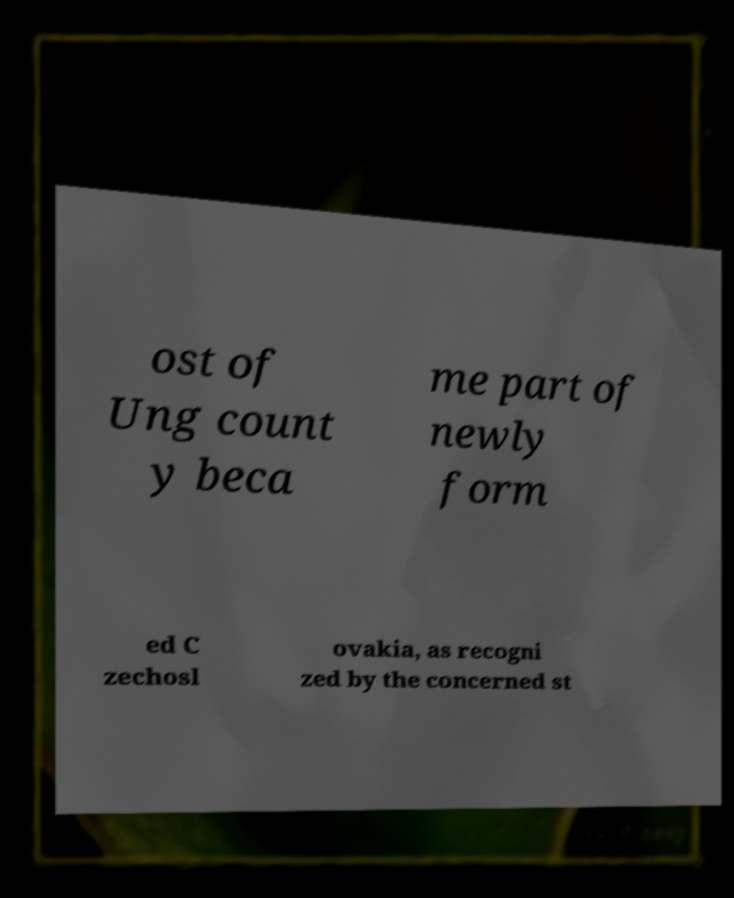Can you accurately transcribe the text from the provided image for me? ost of Ung count y beca me part of newly form ed C zechosl ovakia, as recogni zed by the concerned st 